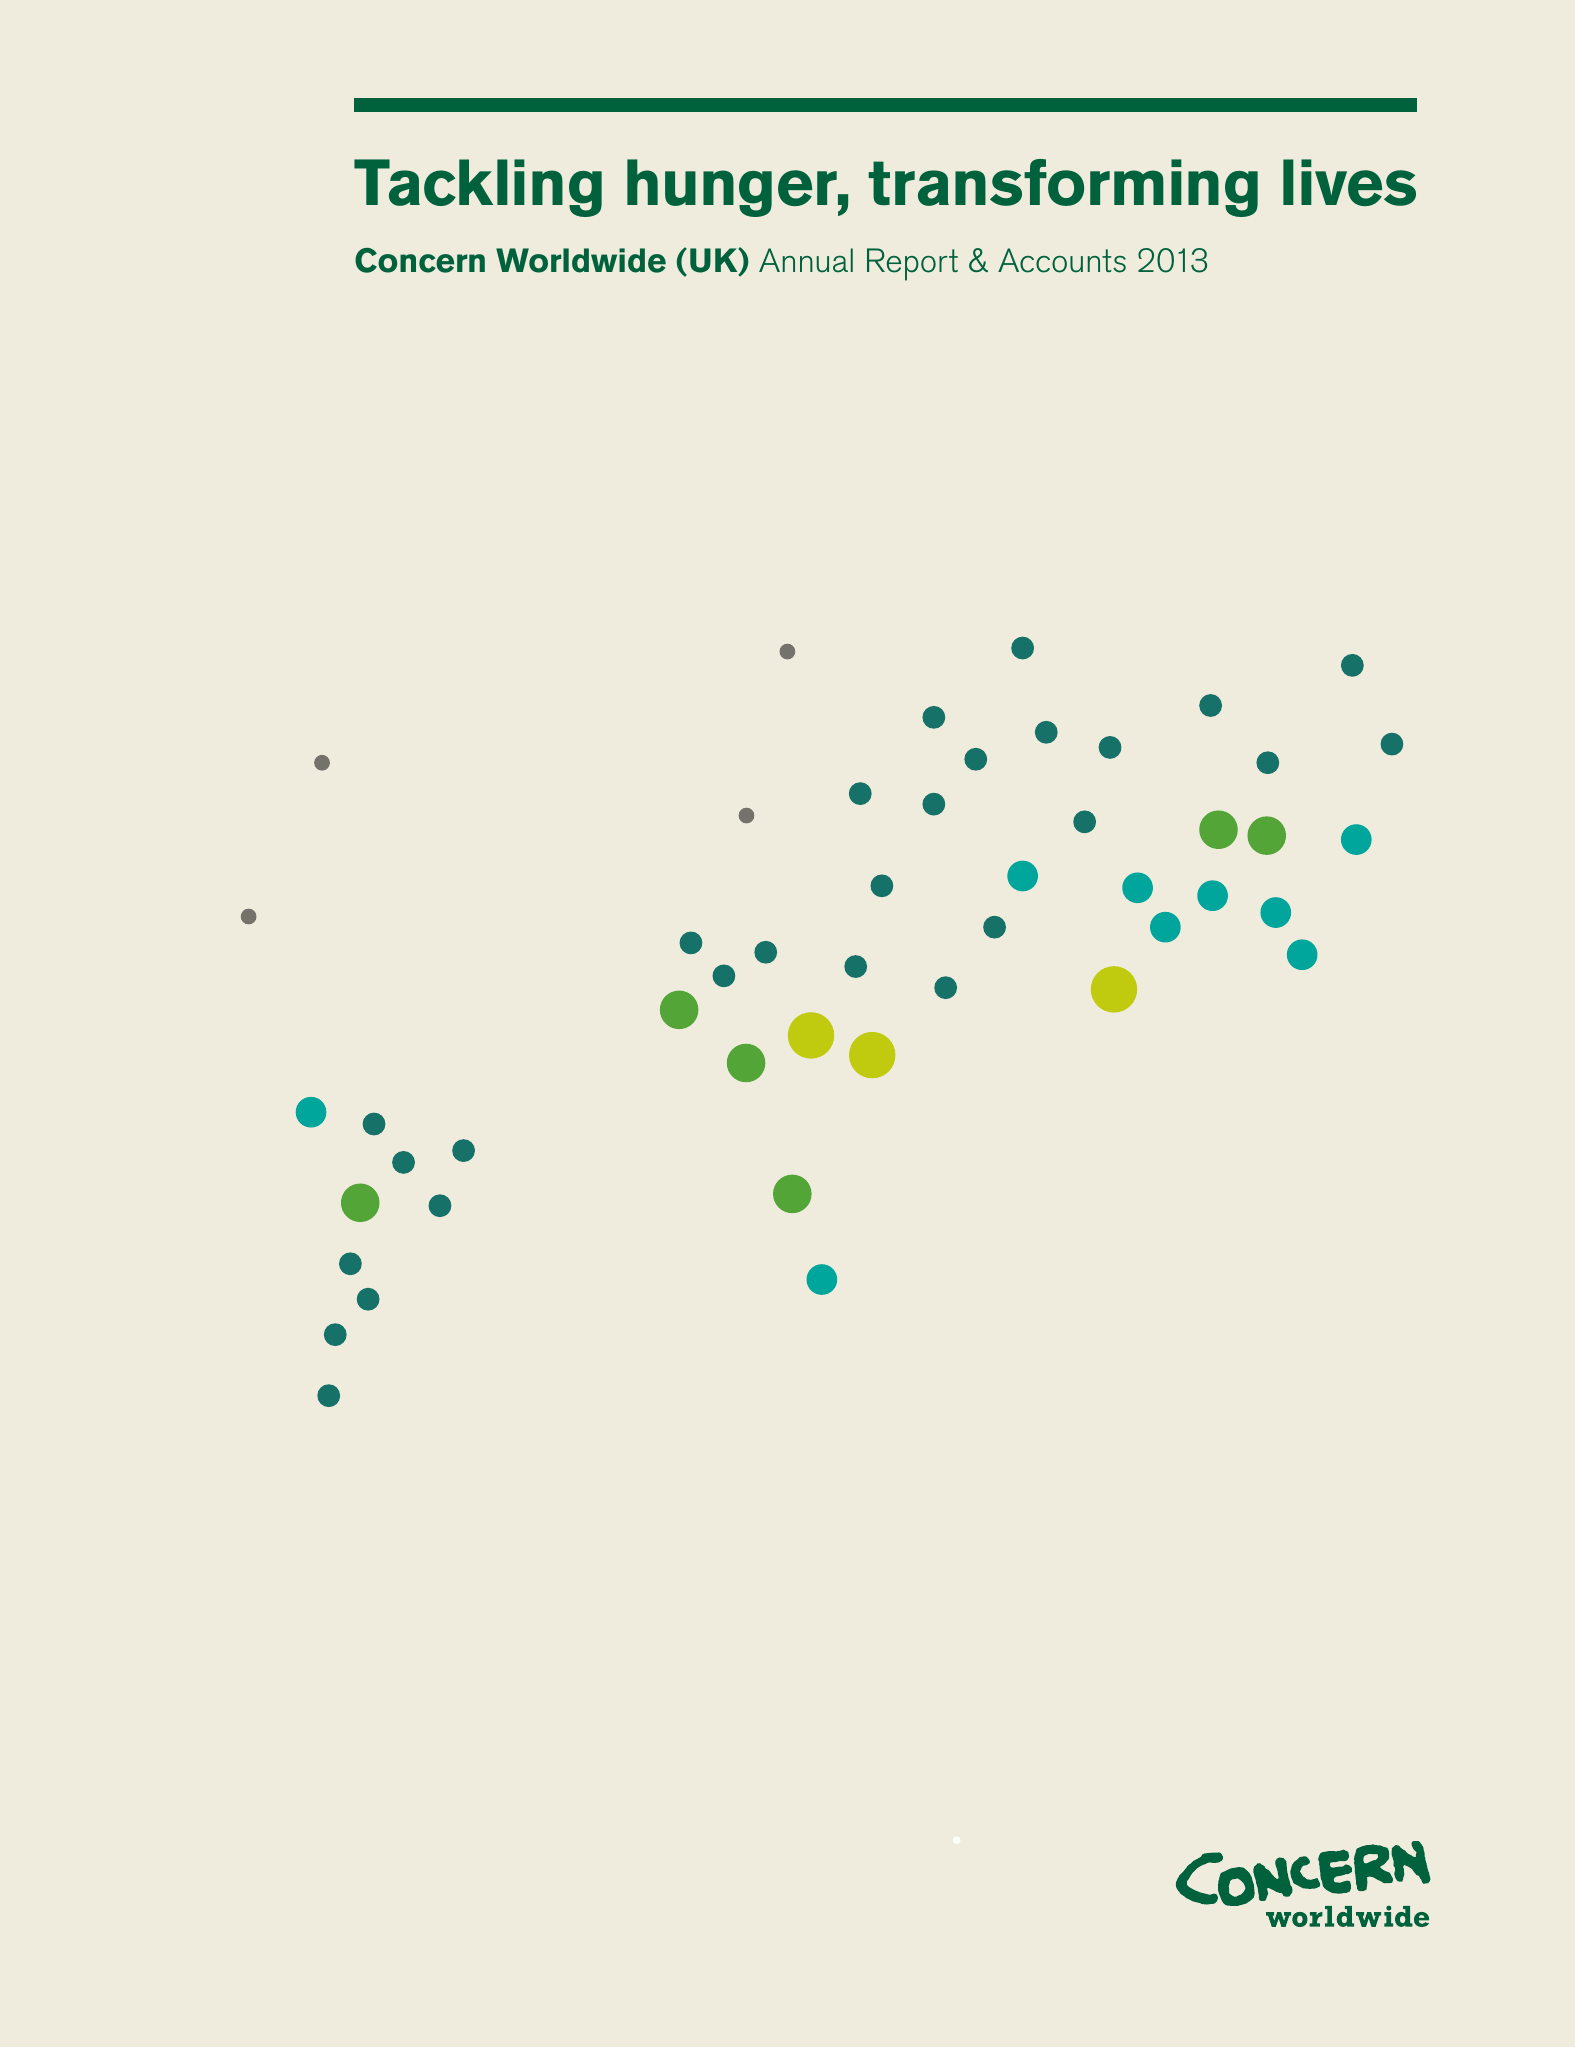What is the value for the report_date?
Answer the question using a single word or phrase. 2013-12-31 